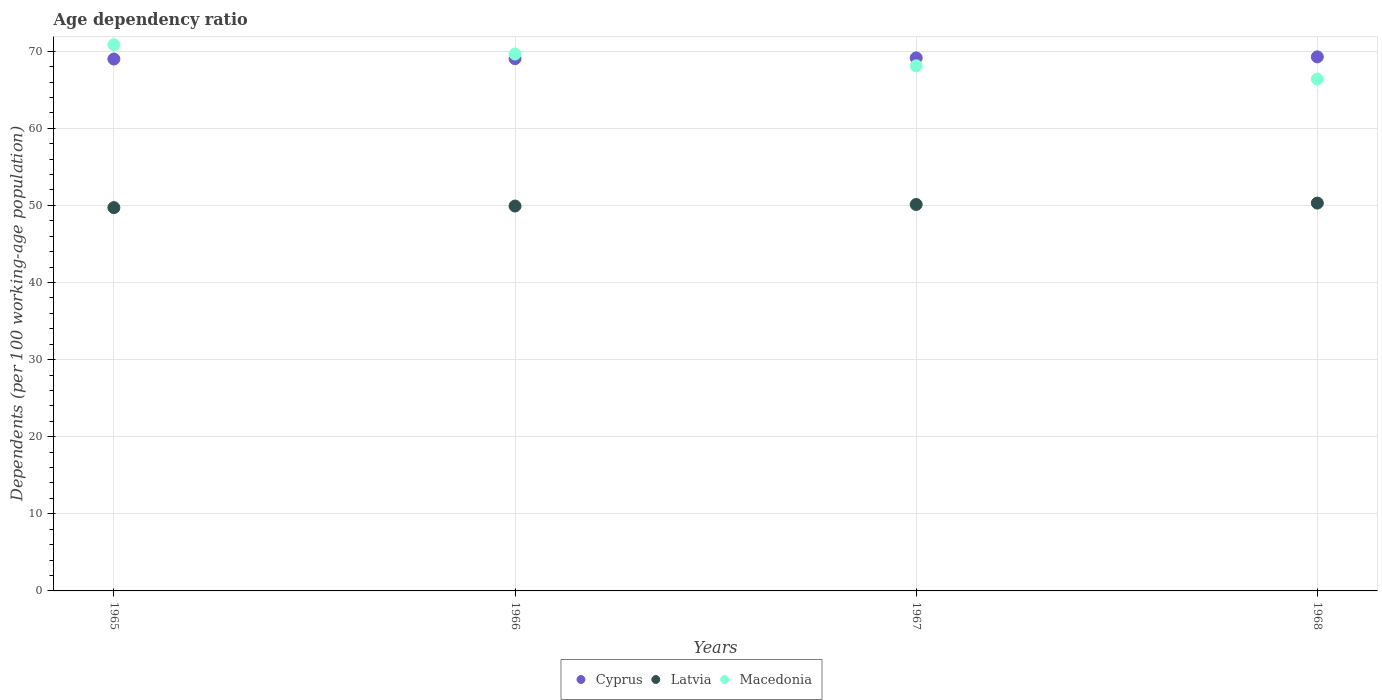Is the number of dotlines equal to the number of legend labels?
Provide a short and direct response. Yes. What is the age dependency ratio in in Latvia in 1968?
Provide a short and direct response. 50.3. Across all years, what is the maximum age dependency ratio in in Latvia?
Your response must be concise. 50.3. Across all years, what is the minimum age dependency ratio in in Cyprus?
Offer a terse response. 68.98. In which year was the age dependency ratio in in Cyprus maximum?
Your answer should be compact. 1968. In which year was the age dependency ratio in in Macedonia minimum?
Your answer should be very brief. 1968. What is the total age dependency ratio in in Cyprus in the graph?
Your answer should be very brief. 276.41. What is the difference between the age dependency ratio in in Latvia in 1965 and that in 1966?
Your answer should be very brief. -0.2. What is the difference between the age dependency ratio in in Latvia in 1966 and the age dependency ratio in in Cyprus in 1967?
Your answer should be very brief. -19.21. What is the average age dependency ratio in in Latvia per year?
Your response must be concise. 50.01. In the year 1968, what is the difference between the age dependency ratio in in Latvia and age dependency ratio in in Macedonia?
Make the answer very short. -16.08. In how many years, is the age dependency ratio in in Macedonia greater than 6 %?
Your answer should be compact. 4. What is the ratio of the age dependency ratio in in Cyprus in 1966 to that in 1968?
Your response must be concise. 1. Is the age dependency ratio in in Latvia in 1965 less than that in 1966?
Ensure brevity in your answer.  Yes. Is the difference between the age dependency ratio in in Latvia in 1967 and 1968 greater than the difference between the age dependency ratio in in Macedonia in 1967 and 1968?
Your answer should be compact. No. What is the difference between the highest and the second highest age dependency ratio in in Macedonia?
Your answer should be very brief. 1.2. What is the difference between the highest and the lowest age dependency ratio in in Macedonia?
Your answer should be compact. 4.45. In how many years, is the age dependency ratio in in Latvia greater than the average age dependency ratio in in Latvia taken over all years?
Your answer should be compact. 2. Does the age dependency ratio in in Macedonia monotonically increase over the years?
Your answer should be compact. No. Is the age dependency ratio in in Macedonia strictly greater than the age dependency ratio in in Cyprus over the years?
Give a very brief answer. No. Is the age dependency ratio in in Latvia strictly less than the age dependency ratio in in Cyprus over the years?
Provide a succinct answer. Yes. How many dotlines are there?
Offer a very short reply. 3. How many years are there in the graph?
Your answer should be very brief. 4. What is the difference between two consecutive major ticks on the Y-axis?
Keep it short and to the point. 10. Are the values on the major ticks of Y-axis written in scientific E-notation?
Ensure brevity in your answer.  No. Does the graph contain grids?
Offer a very short reply. Yes. Where does the legend appear in the graph?
Offer a terse response. Bottom center. How many legend labels are there?
Provide a short and direct response. 3. What is the title of the graph?
Provide a short and direct response. Age dependency ratio. Does "Haiti" appear as one of the legend labels in the graph?
Keep it short and to the point. No. What is the label or title of the X-axis?
Keep it short and to the point. Years. What is the label or title of the Y-axis?
Your response must be concise. Dependents (per 100 working-age population). What is the Dependents (per 100 working-age population) in Cyprus in 1965?
Your answer should be compact. 68.98. What is the Dependents (per 100 working-age population) in Latvia in 1965?
Make the answer very short. 49.71. What is the Dependents (per 100 working-age population) of Macedonia in 1965?
Provide a succinct answer. 70.84. What is the Dependents (per 100 working-age population) in Cyprus in 1966?
Provide a succinct answer. 69.03. What is the Dependents (per 100 working-age population) of Latvia in 1966?
Provide a succinct answer. 49.91. What is the Dependents (per 100 working-age population) of Macedonia in 1966?
Keep it short and to the point. 69.64. What is the Dependents (per 100 working-age population) of Cyprus in 1967?
Give a very brief answer. 69.13. What is the Dependents (per 100 working-age population) of Latvia in 1967?
Your answer should be compact. 50.12. What is the Dependents (per 100 working-age population) of Macedonia in 1967?
Offer a terse response. 68.1. What is the Dependents (per 100 working-age population) in Cyprus in 1968?
Your answer should be compact. 69.26. What is the Dependents (per 100 working-age population) of Latvia in 1968?
Provide a short and direct response. 50.3. What is the Dependents (per 100 working-age population) in Macedonia in 1968?
Keep it short and to the point. 66.39. Across all years, what is the maximum Dependents (per 100 working-age population) in Cyprus?
Provide a short and direct response. 69.26. Across all years, what is the maximum Dependents (per 100 working-age population) in Latvia?
Ensure brevity in your answer.  50.3. Across all years, what is the maximum Dependents (per 100 working-age population) in Macedonia?
Provide a succinct answer. 70.84. Across all years, what is the minimum Dependents (per 100 working-age population) in Cyprus?
Offer a very short reply. 68.98. Across all years, what is the minimum Dependents (per 100 working-age population) in Latvia?
Provide a succinct answer. 49.71. Across all years, what is the minimum Dependents (per 100 working-age population) in Macedonia?
Your response must be concise. 66.39. What is the total Dependents (per 100 working-age population) of Cyprus in the graph?
Your response must be concise. 276.41. What is the total Dependents (per 100 working-age population) of Latvia in the graph?
Provide a short and direct response. 200.05. What is the total Dependents (per 100 working-age population) in Macedonia in the graph?
Offer a very short reply. 274.97. What is the difference between the Dependents (per 100 working-age population) of Cyprus in 1965 and that in 1966?
Offer a terse response. -0.05. What is the difference between the Dependents (per 100 working-age population) of Latvia in 1965 and that in 1966?
Make the answer very short. -0.2. What is the difference between the Dependents (per 100 working-age population) of Macedonia in 1965 and that in 1966?
Keep it short and to the point. 1.2. What is the difference between the Dependents (per 100 working-age population) in Cyprus in 1965 and that in 1967?
Make the answer very short. -0.15. What is the difference between the Dependents (per 100 working-age population) in Latvia in 1965 and that in 1967?
Offer a very short reply. -0.41. What is the difference between the Dependents (per 100 working-age population) in Macedonia in 1965 and that in 1967?
Your answer should be compact. 2.73. What is the difference between the Dependents (per 100 working-age population) of Cyprus in 1965 and that in 1968?
Keep it short and to the point. -0.28. What is the difference between the Dependents (per 100 working-age population) of Latvia in 1965 and that in 1968?
Your answer should be very brief. -0.59. What is the difference between the Dependents (per 100 working-age population) in Macedonia in 1965 and that in 1968?
Ensure brevity in your answer.  4.45. What is the difference between the Dependents (per 100 working-age population) in Cyprus in 1966 and that in 1967?
Provide a succinct answer. -0.1. What is the difference between the Dependents (per 100 working-age population) of Latvia in 1966 and that in 1967?
Keep it short and to the point. -0.2. What is the difference between the Dependents (per 100 working-age population) in Macedonia in 1966 and that in 1967?
Your response must be concise. 1.53. What is the difference between the Dependents (per 100 working-age population) of Cyprus in 1966 and that in 1968?
Your answer should be compact. -0.23. What is the difference between the Dependents (per 100 working-age population) in Latvia in 1966 and that in 1968?
Your answer should be compact. -0.39. What is the difference between the Dependents (per 100 working-age population) in Macedonia in 1966 and that in 1968?
Your response must be concise. 3.25. What is the difference between the Dependents (per 100 working-age population) in Cyprus in 1967 and that in 1968?
Your response must be concise. -0.14. What is the difference between the Dependents (per 100 working-age population) of Latvia in 1967 and that in 1968?
Provide a short and direct response. -0.19. What is the difference between the Dependents (per 100 working-age population) in Macedonia in 1967 and that in 1968?
Keep it short and to the point. 1.72. What is the difference between the Dependents (per 100 working-age population) of Cyprus in 1965 and the Dependents (per 100 working-age population) of Latvia in 1966?
Offer a very short reply. 19.07. What is the difference between the Dependents (per 100 working-age population) of Cyprus in 1965 and the Dependents (per 100 working-age population) of Macedonia in 1966?
Give a very brief answer. -0.65. What is the difference between the Dependents (per 100 working-age population) in Latvia in 1965 and the Dependents (per 100 working-age population) in Macedonia in 1966?
Your response must be concise. -19.93. What is the difference between the Dependents (per 100 working-age population) in Cyprus in 1965 and the Dependents (per 100 working-age population) in Latvia in 1967?
Give a very brief answer. 18.86. What is the difference between the Dependents (per 100 working-age population) in Cyprus in 1965 and the Dependents (per 100 working-age population) in Macedonia in 1967?
Give a very brief answer. 0.88. What is the difference between the Dependents (per 100 working-age population) of Latvia in 1965 and the Dependents (per 100 working-age population) of Macedonia in 1967?
Give a very brief answer. -18.39. What is the difference between the Dependents (per 100 working-age population) in Cyprus in 1965 and the Dependents (per 100 working-age population) in Latvia in 1968?
Your answer should be very brief. 18.68. What is the difference between the Dependents (per 100 working-age population) of Cyprus in 1965 and the Dependents (per 100 working-age population) of Macedonia in 1968?
Provide a short and direct response. 2.6. What is the difference between the Dependents (per 100 working-age population) in Latvia in 1965 and the Dependents (per 100 working-age population) in Macedonia in 1968?
Your answer should be very brief. -16.68. What is the difference between the Dependents (per 100 working-age population) in Cyprus in 1966 and the Dependents (per 100 working-age population) in Latvia in 1967?
Provide a succinct answer. 18.91. What is the difference between the Dependents (per 100 working-age population) of Cyprus in 1966 and the Dependents (per 100 working-age population) of Macedonia in 1967?
Keep it short and to the point. 0.93. What is the difference between the Dependents (per 100 working-age population) of Latvia in 1966 and the Dependents (per 100 working-age population) of Macedonia in 1967?
Provide a succinct answer. -18.19. What is the difference between the Dependents (per 100 working-age population) of Cyprus in 1966 and the Dependents (per 100 working-age population) of Latvia in 1968?
Ensure brevity in your answer.  18.73. What is the difference between the Dependents (per 100 working-age population) of Cyprus in 1966 and the Dependents (per 100 working-age population) of Macedonia in 1968?
Your response must be concise. 2.64. What is the difference between the Dependents (per 100 working-age population) in Latvia in 1966 and the Dependents (per 100 working-age population) in Macedonia in 1968?
Your response must be concise. -16.47. What is the difference between the Dependents (per 100 working-age population) of Cyprus in 1967 and the Dependents (per 100 working-age population) of Latvia in 1968?
Give a very brief answer. 18.82. What is the difference between the Dependents (per 100 working-age population) in Cyprus in 1967 and the Dependents (per 100 working-age population) in Macedonia in 1968?
Your answer should be very brief. 2.74. What is the difference between the Dependents (per 100 working-age population) of Latvia in 1967 and the Dependents (per 100 working-age population) of Macedonia in 1968?
Offer a terse response. -16.27. What is the average Dependents (per 100 working-age population) of Cyprus per year?
Your answer should be very brief. 69.1. What is the average Dependents (per 100 working-age population) in Latvia per year?
Your answer should be compact. 50.01. What is the average Dependents (per 100 working-age population) in Macedonia per year?
Provide a short and direct response. 68.74. In the year 1965, what is the difference between the Dependents (per 100 working-age population) of Cyprus and Dependents (per 100 working-age population) of Latvia?
Your answer should be very brief. 19.27. In the year 1965, what is the difference between the Dependents (per 100 working-age population) of Cyprus and Dependents (per 100 working-age population) of Macedonia?
Your response must be concise. -1.86. In the year 1965, what is the difference between the Dependents (per 100 working-age population) in Latvia and Dependents (per 100 working-age population) in Macedonia?
Offer a terse response. -21.13. In the year 1966, what is the difference between the Dependents (per 100 working-age population) of Cyprus and Dependents (per 100 working-age population) of Latvia?
Your answer should be very brief. 19.12. In the year 1966, what is the difference between the Dependents (per 100 working-age population) in Cyprus and Dependents (per 100 working-age population) in Macedonia?
Provide a short and direct response. -0.61. In the year 1966, what is the difference between the Dependents (per 100 working-age population) in Latvia and Dependents (per 100 working-age population) in Macedonia?
Keep it short and to the point. -19.72. In the year 1967, what is the difference between the Dependents (per 100 working-age population) in Cyprus and Dependents (per 100 working-age population) in Latvia?
Ensure brevity in your answer.  19.01. In the year 1967, what is the difference between the Dependents (per 100 working-age population) in Cyprus and Dependents (per 100 working-age population) in Macedonia?
Make the answer very short. 1.02. In the year 1967, what is the difference between the Dependents (per 100 working-age population) of Latvia and Dependents (per 100 working-age population) of Macedonia?
Offer a very short reply. -17.99. In the year 1968, what is the difference between the Dependents (per 100 working-age population) of Cyprus and Dependents (per 100 working-age population) of Latvia?
Make the answer very short. 18.96. In the year 1968, what is the difference between the Dependents (per 100 working-age population) in Cyprus and Dependents (per 100 working-age population) in Macedonia?
Your answer should be compact. 2.88. In the year 1968, what is the difference between the Dependents (per 100 working-age population) of Latvia and Dependents (per 100 working-age population) of Macedonia?
Provide a short and direct response. -16.08. What is the ratio of the Dependents (per 100 working-age population) of Latvia in 1965 to that in 1966?
Ensure brevity in your answer.  1. What is the ratio of the Dependents (per 100 working-age population) of Macedonia in 1965 to that in 1966?
Provide a succinct answer. 1.02. What is the ratio of the Dependents (per 100 working-age population) in Cyprus in 1965 to that in 1967?
Your answer should be very brief. 1. What is the ratio of the Dependents (per 100 working-age population) in Macedonia in 1965 to that in 1967?
Your response must be concise. 1.04. What is the ratio of the Dependents (per 100 working-age population) of Latvia in 1965 to that in 1968?
Ensure brevity in your answer.  0.99. What is the ratio of the Dependents (per 100 working-age population) of Macedonia in 1965 to that in 1968?
Offer a very short reply. 1.07. What is the ratio of the Dependents (per 100 working-age population) in Cyprus in 1966 to that in 1967?
Your answer should be very brief. 1. What is the ratio of the Dependents (per 100 working-age population) in Macedonia in 1966 to that in 1967?
Your answer should be very brief. 1.02. What is the ratio of the Dependents (per 100 working-age population) of Cyprus in 1966 to that in 1968?
Your response must be concise. 1. What is the ratio of the Dependents (per 100 working-age population) of Latvia in 1966 to that in 1968?
Offer a terse response. 0.99. What is the ratio of the Dependents (per 100 working-age population) of Macedonia in 1966 to that in 1968?
Your response must be concise. 1.05. What is the ratio of the Dependents (per 100 working-age population) of Cyprus in 1967 to that in 1968?
Make the answer very short. 1. What is the ratio of the Dependents (per 100 working-age population) of Macedonia in 1967 to that in 1968?
Your answer should be compact. 1.03. What is the difference between the highest and the second highest Dependents (per 100 working-age population) in Cyprus?
Make the answer very short. 0.14. What is the difference between the highest and the second highest Dependents (per 100 working-age population) of Latvia?
Your answer should be compact. 0.19. What is the difference between the highest and the second highest Dependents (per 100 working-age population) of Macedonia?
Your answer should be very brief. 1.2. What is the difference between the highest and the lowest Dependents (per 100 working-age population) of Cyprus?
Provide a short and direct response. 0.28. What is the difference between the highest and the lowest Dependents (per 100 working-age population) in Latvia?
Offer a very short reply. 0.59. What is the difference between the highest and the lowest Dependents (per 100 working-age population) in Macedonia?
Provide a succinct answer. 4.45. 